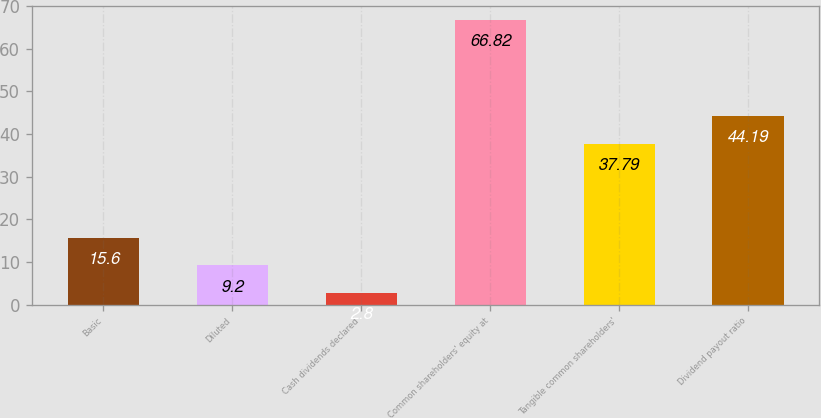Convert chart to OTSL. <chart><loc_0><loc_0><loc_500><loc_500><bar_chart><fcel>Basic<fcel>Diluted<fcel>Cash dividends declared<fcel>Common shareholders' equity at<fcel>Tangible common shareholders'<fcel>Dividend payout ratio<nl><fcel>15.6<fcel>9.2<fcel>2.8<fcel>66.82<fcel>37.79<fcel>44.19<nl></chart> 